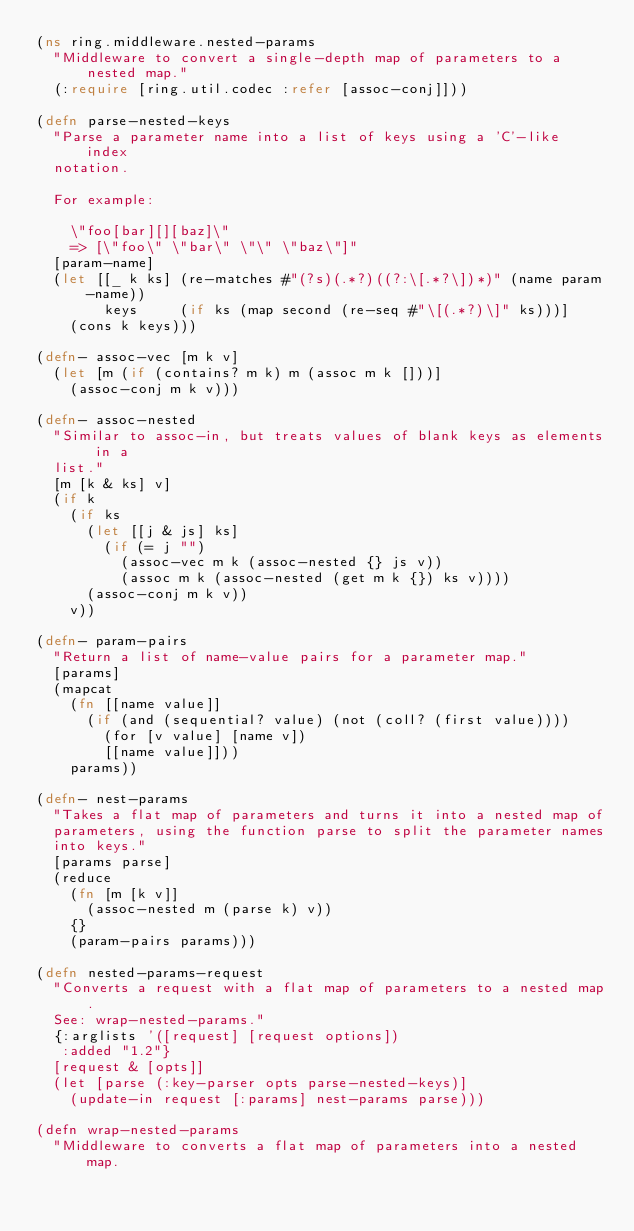Convert code to text. <code><loc_0><loc_0><loc_500><loc_500><_Clojure_>(ns ring.middleware.nested-params
  "Middleware to convert a single-depth map of parameters to a nested map."
  (:require [ring.util.codec :refer [assoc-conj]]))

(defn parse-nested-keys
  "Parse a parameter name into a list of keys using a 'C'-like index
  notation.

  For example:

    \"foo[bar][][baz]\"
    => [\"foo\" \"bar\" \"\" \"baz\"]"
  [param-name]
  (let [[_ k ks] (re-matches #"(?s)(.*?)((?:\[.*?\])*)" (name param-name))
        keys     (if ks (map second (re-seq #"\[(.*?)\]" ks)))]
    (cons k keys)))

(defn- assoc-vec [m k v]
  (let [m (if (contains? m k) m (assoc m k []))]
    (assoc-conj m k v)))

(defn- assoc-nested
  "Similar to assoc-in, but treats values of blank keys as elements in a
  list."
  [m [k & ks] v]
  (if k
    (if ks
      (let [[j & js] ks]
        (if (= j "")
          (assoc-vec m k (assoc-nested {} js v))
          (assoc m k (assoc-nested (get m k {}) ks v))))
      (assoc-conj m k v))
    v))

(defn- param-pairs
  "Return a list of name-value pairs for a parameter map."
  [params]
  (mapcat
    (fn [[name value]]
      (if (and (sequential? value) (not (coll? (first value))))
        (for [v value] [name v])
        [[name value]]))
    params))

(defn- nest-params
  "Takes a flat map of parameters and turns it into a nested map of
  parameters, using the function parse to split the parameter names
  into keys."
  [params parse]
  (reduce
    (fn [m [k v]]
      (assoc-nested m (parse k) v))
    {}
    (param-pairs params)))

(defn nested-params-request
  "Converts a request with a flat map of parameters to a nested map.
  See: wrap-nested-params."
  {:arglists '([request] [request options])
   :added "1.2"}
  [request & [opts]]
  (let [parse (:key-parser opts parse-nested-keys)]
    (update-in request [:params] nest-params parse)))

(defn wrap-nested-params
  "Middleware to converts a flat map of parameters into a nested map.</code> 